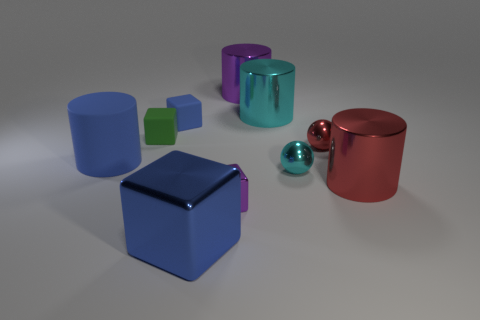Subtract all balls. How many objects are left? 8 Add 9 red balls. How many red balls are left? 10 Add 1 small blue matte cubes. How many small blue matte cubes exist? 2 Subtract 0 red cubes. How many objects are left? 10 Subtract all cylinders. Subtract all blue metal cubes. How many objects are left? 5 